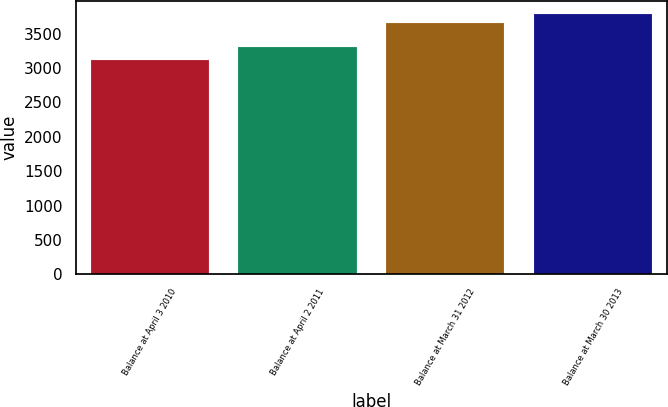<chart> <loc_0><loc_0><loc_500><loc_500><bar_chart><fcel>Balance at April 3 2010<fcel>Balance at April 2 2011<fcel>Balance at March 31 2012<fcel>Balance at March 30 2013<nl><fcel>3116.6<fcel>3304.7<fcel>3652.5<fcel>3784.6<nl></chart> 